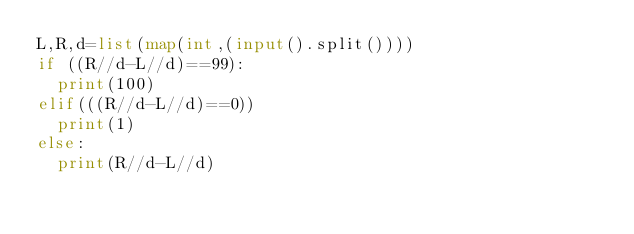<code> <loc_0><loc_0><loc_500><loc_500><_Python_>L,R,d=list(map(int,(input().split())))
if ((R//d-L//d)==99):
  print(100)
elif(((R//d-L//d)==0))
  print(1)
else:
  print(R//d-L//d)</code> 